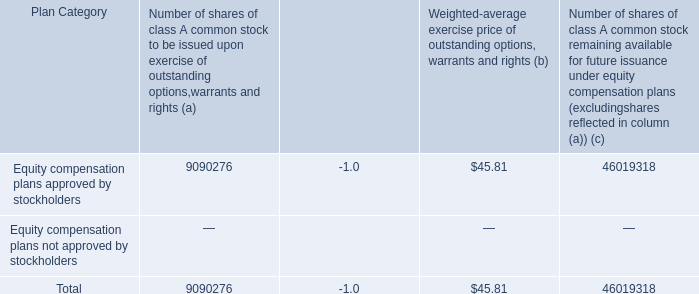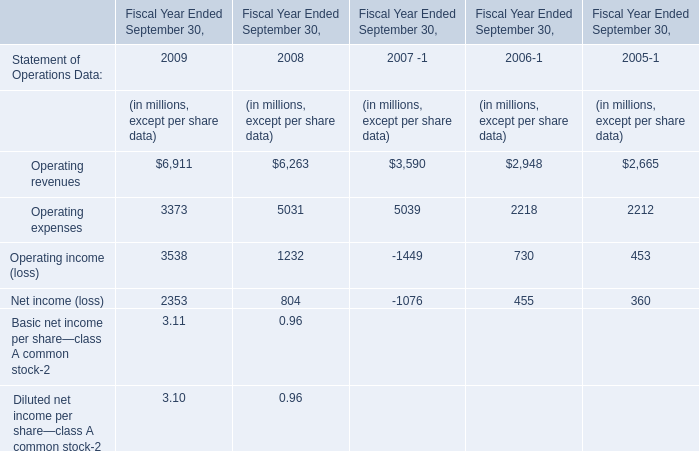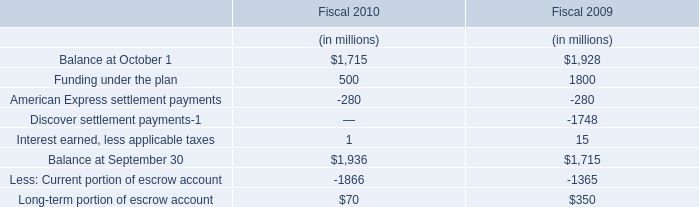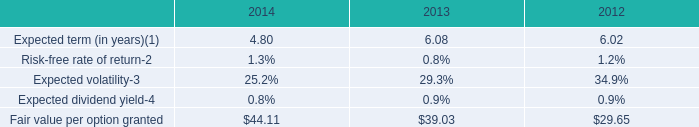How many kinds of operating in 2009 are greater than those in the previous year? 
Answer: operating revenue and operating income(loss). 